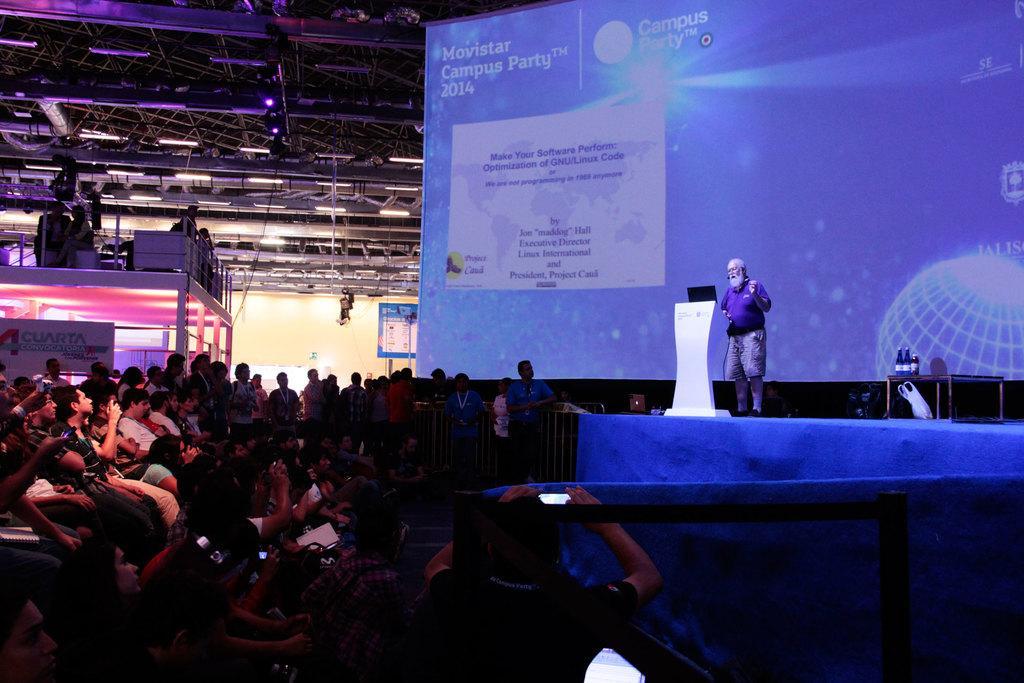How would you summarize this image in a sentence or two? In this picture we can see an old man standing on the stage & down the stage we have many people sitting and watching him. 